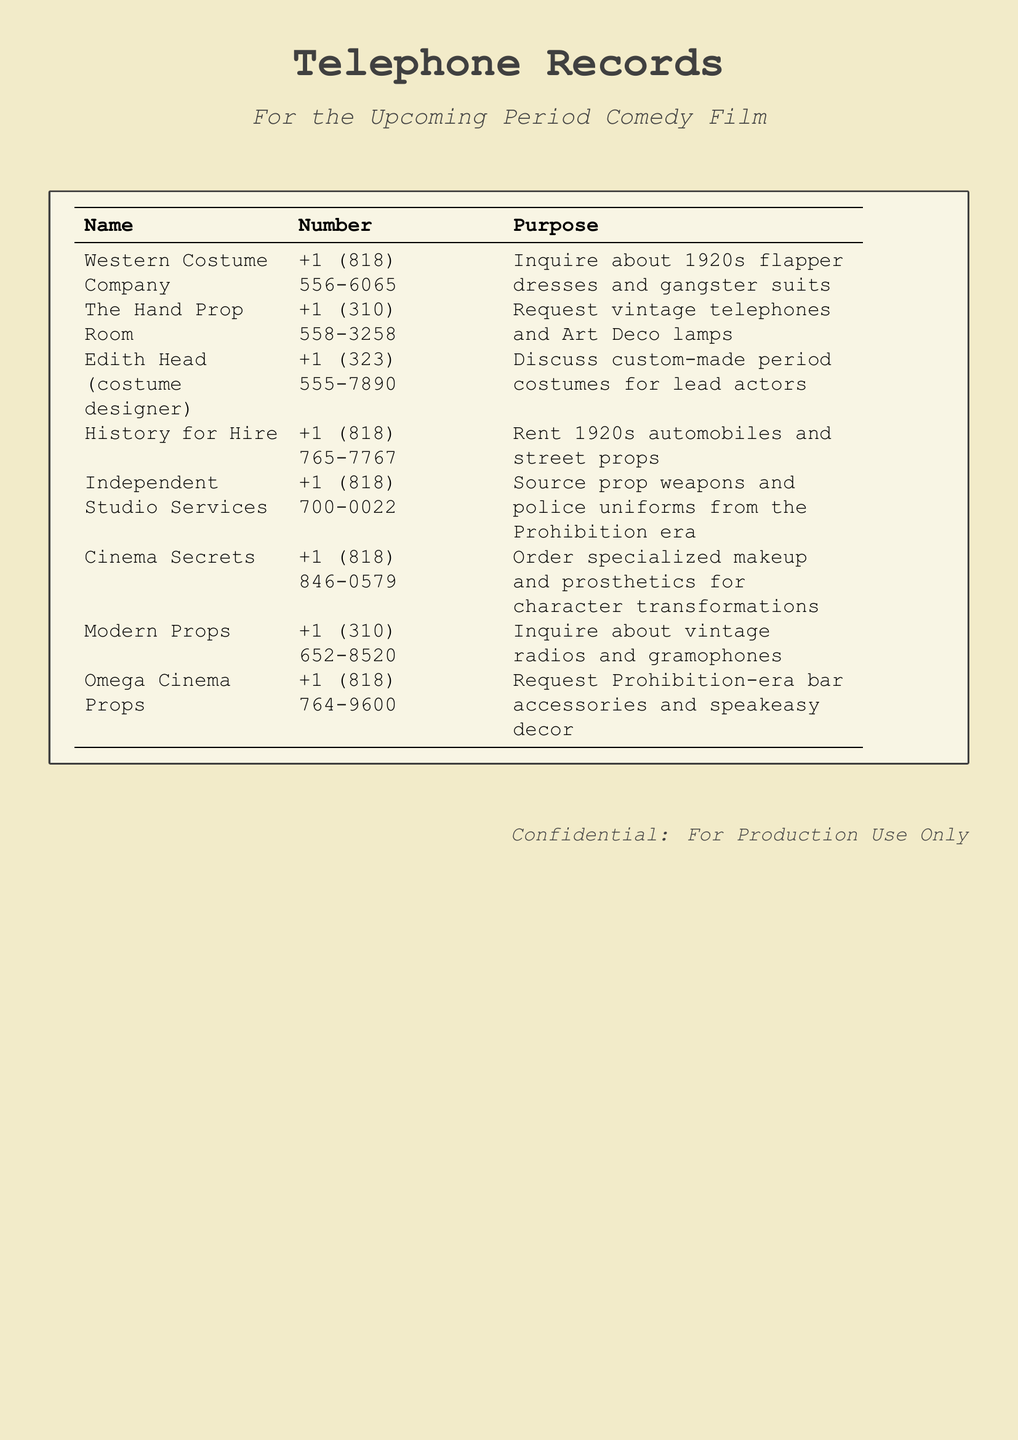What is the name of the company that provides flapper dresses? The document lists the Western Costume Company as the provider of flapper dresses.
Answer: Western Costume Company What is the phone number for The Hand Prop Room? The phone number listed for The Hand Prop Room is +1 (310) 558-3258.
Answer: +1 (310) 558-3258 Which designer is mentioned for custom-made period costumes? The document specifies Edith Head as the costume designer for custom-made costumes.
Answer: Edith Head How many prop houses are listed in the document? The document contains a total of seven prop houses or costume designers.
Answer: Seven What type of props does History for Hire offer? History for Hire offers 1920s automobiles and street props.
Answer: 1920s automobiles and street props What type of items did Omega Cinema Props request? Omega Cinema Props requested Prohibition-era bar accessories and speakeasy decor.
Answer: Prohibition-era bar accessories and speakeasy decor Which company is contacted for specialized makeup? The company listed for specialized makeup is Cinema Secrets.
Answer: Cinema Secrets What is the purpose of the call to Independent Studio Services? The purpose is to source prop weapons and police uniforms from the Prohibition era.
Answer: Source prop weapons and police uniforms from the Prohibition era 